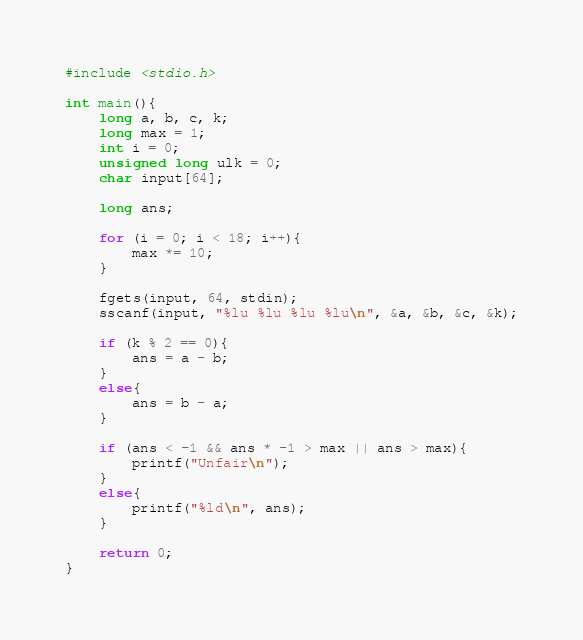<code> <loc_0><loc_0><loc_500><loc_500><_C_>#include <stdio.h>

int main(){
    long a, b, c, k;
    long max = 1;
    int i = 0;
    unsigned long ulk = 0;
    char input[64];

    long ans;

    for (i = 0; i < 18; i++){
        max *= 10;
    }

    fgets(input, 64, stdin);
    sscanf(input, "%lu %lu %lu %lu\n", &a, &b, &c, &k);

    if (k % 2 == 0){
        ans = a - b;
    }
    else{
        ans = b - a;
    }

    if (ans < -1 && ans * -1 > max || ans > max){
        printf("Unfair\n");
    }
    else{
        printf("%ld\n", ans);
    }

    return 0;
}</code> 